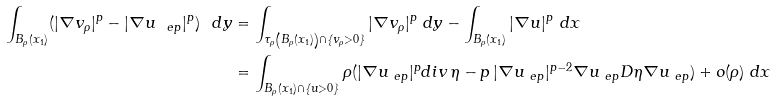Convert formula to latex. <formula><loc_0><loc_0><loc_500><loc_500>\int _ { B _ { \rho } ( x _ { 1 } ) } ( | \nabla v _ { \rho } | ^ { p } - | \nabla u _ { \ e p } | ^ { p } ) \ d y & = \int _ { \tau _ { \rho } \left ( B _ { \rho } ( x _ { 1 } ) \right ) \cap \{ v _ { \rho } > 0 \} } | \nabla v _ { \rho } | ^ { p } \ d y - \int _ { B _ { \rho } ( x _ { 1 } ) } | \nabla u | ^ { p } \ d x \\ & = \int _ { B _ { \rho } ( x _ { 1 } ) \cap \{ u > 0 \} } \rho ( | \nabla u _ { \ e p } | ^ { p } d i v \, \eta - p \, | \nabla u _ { \ e p } | ^ { p - 2 } \nabla u _ { \ e p } D \eta \nabla u _ { \ e p } ) + o ( \rho ) \ d x</formula> 